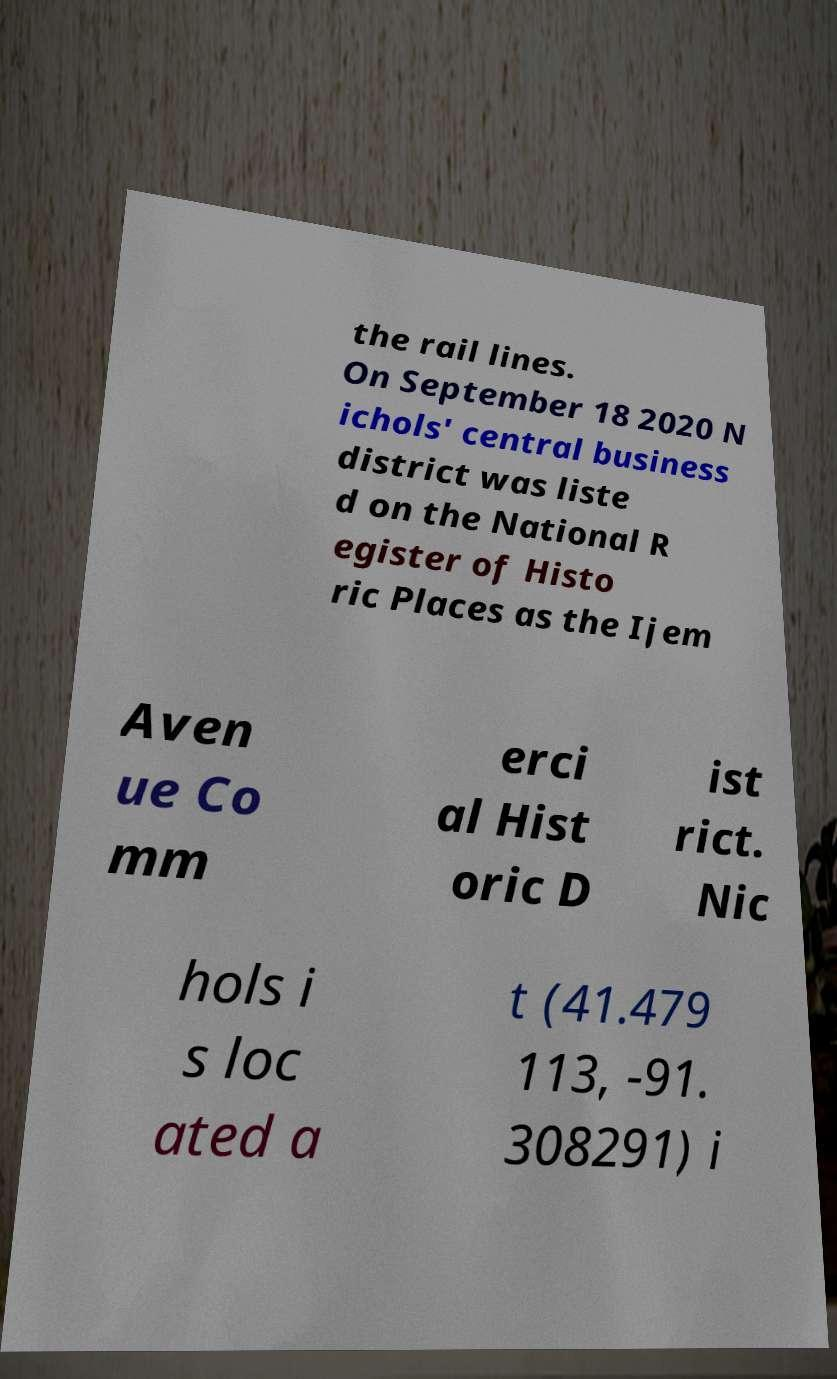For documentation purposes, I need the text within this image transcribed. Could you provide that? the rail lines. On September 18 2020 N ichols' central business district was liste d on the National R egister of Histo ric Places as the Ijem Aven ue Co mm erci al Hist oric D ist rict. Nic hols i s loc ated a t (41.479 113, -91. 308291) i 